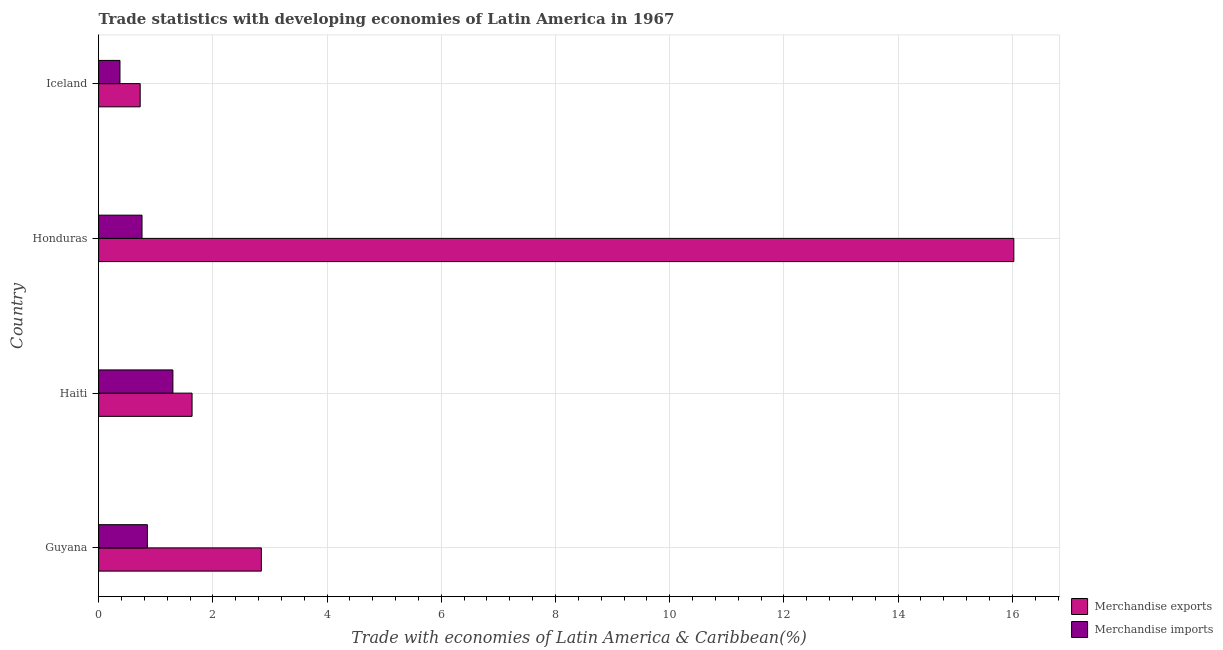How many different coloured bars are there?
Your answer should be compact. 2. How many groups of bars are there?
Offer a terse response. 4. Are the number of bars on each tick of the Y-axis equal?
Offer a very short reply. Yes. How many bars are there on the 4th tick from the top?
Make the answer very short. 2. How many bars are there on the 2nd tick from the bottom?
Your response must be concise. 2. What is the label of the 3rd group of bars from the top?
Ensure brevity in your answer.  Haiti. What is the merchandise exports in Honduras?
Your response must be concise. 16.03. Across all countries, what is the maximum merchandise imports?
Offer a terse response. 1.3. Across all countries, what is the minimum merchandise exports?
Offer a very short reply. 0.73. In which country was the merchandise imports maximum?
Your answer should be compact. Haiti. In which country was the merchandise exports minimum?
Provide a short and direct response. Iceland. What is the total merchandise imports in the graph?
Your answer should be very brief. 3.29. What is the difference between the merchandise imports in Guyana and that in Haiti?
Provide a succinct answer. -0.45. What is the difference between the merchandise imports in Honduras and the merchandise exports in Haiti?
Offer a very short reply. -0.88. What is the average merchandise exports per country?
Keep it short and to the point. 5.31. What is the difference between the merchandise exports and merchandise imports in Haiti?
Provide a succinct answer. 0.34. In how many countries, is the merchandise imports greater than 15.2 %?
Give a very brief answer. 0. What is the ratio of the merchandise imports in Guyana to that in Haiti?
Offer a terse response. 0.66. What is the difference between the highest and the second highest merchandise exports?
Make the answer very short. 13.18. In how many countries, is the merchandise exports greater than the average merchandise exports taken over all countries?
Your answer should be compact. 1. Is the sum of the merchandise exports in Guyana and Iceland greater than the maximum merchandise imports across all countries?
Provide a short and direct response. Yes. What does the 1st bar from the bottom in Haiti represents?
Keep it short and to the point. Merchandise exports. How many bars are there?
Provide a succinct answer. 8. How many countries are there in the graph?
Give a very brief answer. 4. Are the values on the major ticks of X-axis written in scientific E-notation?
Your answer should be compact. No. Does the graph contain grids?
Offer a terse response. Yes. How are the legend labels stacked?
Give a very brief answer. Vertical. What is the title of the graph?
Give a very brief answer. Trade statistics with developing economies of Latin America in 1967. Does "Sanitation services" appear as one of the legend labels in the graph?
Keep it short and to the point. No. What is the label or title of the X-axis?
Keep it short and to the point. Trade with economies of Latin America & Caribbean(%). What is the label or title of the Y-axis?
Your response must be concise. Country. What is the Trade with economies of Latin America & Caribbean(%) of Merchandise exports in Guyana?
Ensure brevity in your answer.  2.85. What is the Trade with economies of Latin America & Caribbean(%) in Merchandise imports in Guyana?
Offer a very short reply. 0.85. What is the Trade with economies of Latin America & Caribbean(%) of Merchandise exports in Haiti?
Provide a short and direct response. 1.64. What is the Trade with economies of Latin America & Caribbean(%) of Merchandise imports in Haiti?
Your answer should be compact. 1.3. What is the Trade with economies of Latin America & Caribbean(%) of Merchandise exports in Honduras?
Your answer should be very brief. 16.03. What is the Trade with economies of Latin America & Caribbean(%) of Merchandise imports in Honduras?
Give a very brief answer. 0.76. What is the Trade with economies of Latin America & Caribbean(%) of Merchandise exports in Iceland?
Keep it short and to the point. 0.73. What is the Trade with economies of Latin America & Caribbean(%) of Merchandise imports in Iceland?
Provide a short and direct response. 0.37. Across all countries, what is the maximum Trade with economies of Latin America & Caribbean(%) of Merchandise exports?
Make the answer very short. 16.03. Across all countries, what is the maximum Trade with economies of Latin America & Caribbean(%) in Merchandise imports?
Keep it short and to the point. 1.3. Across all countries, what is the minimum Trade with economies of Latin America & Caribbean(%) in Merchandise exports?
Offer a terse response. 0.73. Across all countries, what is the minimum Trade with economies of Latin America & Caribbean(%) of Merchandise imports?
Your answer should be compact. 0.37. What is the total Trade with economies of Latin America & Caribbean(%) in Merchandise exports in the graph?
Offer a terse response. 21.24. What is the total Trade with economies of Latin America & Caribbean(%) in Merchandise imports in the graph?
Provide a succinct answer. 3.29. What is the difference between the Trade with economies of Latin America & Caribbean(%) of Merchandise exports in Guyana and that in Haiti?
Give a very brief answer. 1.21. What is the difference between the Trade with economies of Latin America & Caribbean(%) of Merchandise imports in Guyana and that in Haiti?
Your response must be concise. -0.45. What is the difference between the Trade with economies of Latin America & Caribbean(%) in Merchandise exports in Guyana and that in Honduras?
Ensure brevity in your answer.  -13.18. What is the difference between the Trade with economies of Latin America & Caribbean(%) of Merchandise imports in Guyana and that in Honduras?
Provide a short and direct response. 0.09. What is the difference between the Trade with economies of Latin America & Caribbean(%) in Merchandise exports in Guyana and that in Iceland?
Ensure brevity in your answer.  2.12. What is the difference between the Trade with economies of Latin America & Caribbean(%) of Merchandise imports in Guyana and that in Iceland?
Your answer should be compact. 0.48. What is the difference between the Trade with economies of Latin America & Caribbean(%) of Merchandise exports in Haiti and that in Honduras?
Provide a short and direct response. -14.39. What is the difference between the Trade with economies of Latin America & Caribbean(%) of Merchandise imports in Haiti and that in Honduras?
Make the answer very short. 0.54. What is the difference between the Trade with economies of Latin America & Caribbean(%) of Merchandise exports in Haiti and that in Iceland?
Give a very brief answer. 0.91. What is the difference between the Trade with economies of Latin America & Caribbean(%) in Merchandise imports in Haiti and that in Iceland?
Give a very brief answer. 0.93. What is the difference between the Trade with economies of Latin America & Caribbean(%) of Merchandise exports in Honduras and that in Iceland?
Make the answer very short. 15.3. What is the difference between the Trade with economies of Latin America & Caribbean(%) in Merchandise imports in Honduras and that in Iceland?
Offer a terse response. 0.39. What is the difference between the Trade with economies of Latin America & Caribbean(%) of Merchandise exports in Guyana and the Trade with economies of Latin America & Caribbean(%) of Merchandise imports in Haiti?
Your answer should be very brief. 1.55. What is the difference between the Trade with economies of Latin America & Caribbean(%) in Merchandise exports in Guyana and the Trade with economies of Latin America & Caribbean(%) in Merchandise imports in Honduras?
Keep it short and to the point. 2.09. What is the difference between the Trade with economies of Latin America & Caribbean(%) of Merchandise exports in Guyana and the Trade with economies of Latin America & Caribbean(%) of Merchandise imports in Iceland?
Offer a terse response. 2.48. What is the difference between the Trade with economies of Latin America & Caribbean(%) in Merchandise exports in Haiti and the Trade with economies of Latin America & Caribbean(%) in Merchandise imports in Honduras?
Your answer should be very brief. 0.88. What is the difference between the Trade with economies of Latin America & Caribbean(%) of Merchandise exports in Haiti and the Trade with economies of Latin America & Caribbean(%) of Merchandise imports in Iceland?
Offer a very short reply. 1.26. What is the difference between the Trade with economies of Latin America & Caribbean(%) in Merchandise exports in Honduras and the Trade with economies of Latin America & Caribbean(%) in Merchandise imports in Iceland?
Give a very brief answer. 15.65. What is the average Trade with economies of Latin America & Caribbean(%) in Merchandise exports per country?
Keep it short and to the point. 5.31. What is the average Trade with economies of Latin America & Caribbean(%) in Merchandise imports per country?
Your answer should be compact. 0.82. What is the difference between the Trade with economies of Latin America & Caribbean(%) in Merchandise exports and Trade with economies of Latin America & Caribbean(%) in Merchandise imports in Guyana?
Make the answer very short. 2. What is the difference between the Trade with economies of Latin America & Caribbean(%) in Merchandise exports and Trade with economies of Latin America & Caribbean(%) in Merchandise imports in Haiti?
Your answer should be compact. 0.34. What is the difference between the Trade with economies of Latin America & Caribbean(%) in Merchandise exports and Trade with economies of Latin America & Caribbean(%) in Merchandise imports in Honduras?
Give a very brief answer. 15.27. What is the difference between the Trade with economies of Latin America & Caribbean(%) in Merchandise exports and Trade with economies of Latin America & Caribbean(%) in Merchandise imports in Iceland?
Your response must be concise. 0.35. What is the ratio of the Trade with economies of Latin America & Caribbean(%) in Merchandise exports in Guyana to that in Haiti?
Offer a terse response. 1.74. What is the ratio of the Trade with economies of Latin America & Caribbean(%) in Merchandise imports in Guyana to that in Haiti?
Provide a short and direct response. 0.66. What is the ratio of the Trade with economies of Latin America & Caribbean(%) of Merchandise exports in Guyana to that in Honduras?
Offer a terse response. 0.18. What is the ratio of the Trade with economies of Latin America & Caribbean(%) in Merchandise imports in Guyana to that in Honduras?
Your answer should be compact. 1.12. What is the ratio of the Trade with economies of Latin America & Caribbean(%) of Merchandise exports in Guyana to that in Iceland?
Offer a very short reply. 3.92. What is the ratio of the Trade with economies of Latin America & Caribbean(%) in Merchandise imports in Guyana to that in Iceland?
Your response must be concise. 2.28. What is the ratio of the Trade with economies of Latin America & Caribbean(%) in Merchandise exports in Haiti to that in Honduras?
Offer a terse response. 0.1. What is the ratio of the Trade with economies of Latin America & Caribbean(%) of Merchandise imports in Haiti to that in Honduras?
Provide a short and direct response. 1.71. What is the ratio of the Trade with economies of Latin America & Caribbean(%) in Merchandise exports in Haiti to that in Iceland?
Your response must be concise. 2.25. What is the ratio of the Trade with economies of Latin America & Caribbean(%) of Merchandise imports in Haiti to that in Iceland?
Provide a short and direct response. 3.48. What is the ratio of the Trade with economies of Latin America & Caribbean(%) of Merchandise exports in Honduras to that in Iceland?
Your response must be concise. 22.02. What is the ratio of the Trade with economies of Latin America & Caribbean(%) in Merchandise imports in Honduras to that in Iceland?
Make the answer very short. 2.03. What is the difference between the highest and the second highest Trade with economies of Latin America & Caribbean(%) in Merchandise exports?
Provide a short and direct response. 13.18. What is the difference between the highest and the second highest Trade with economies of Latin America & Caribbean(%) in Merchandise imports?
Ensure brevity in your answer.  0.45. What is the difference between the highest and the lowest Trade with economies of Latin America & Caribbean(%) of Merchandise exports?
Give a very brief answer. 15.3. What is the difference between the highest and the lowest Trade with economies of Latin America & Caribbean(%) in Merchandise imports?
Your response must be concise. 0.93. 